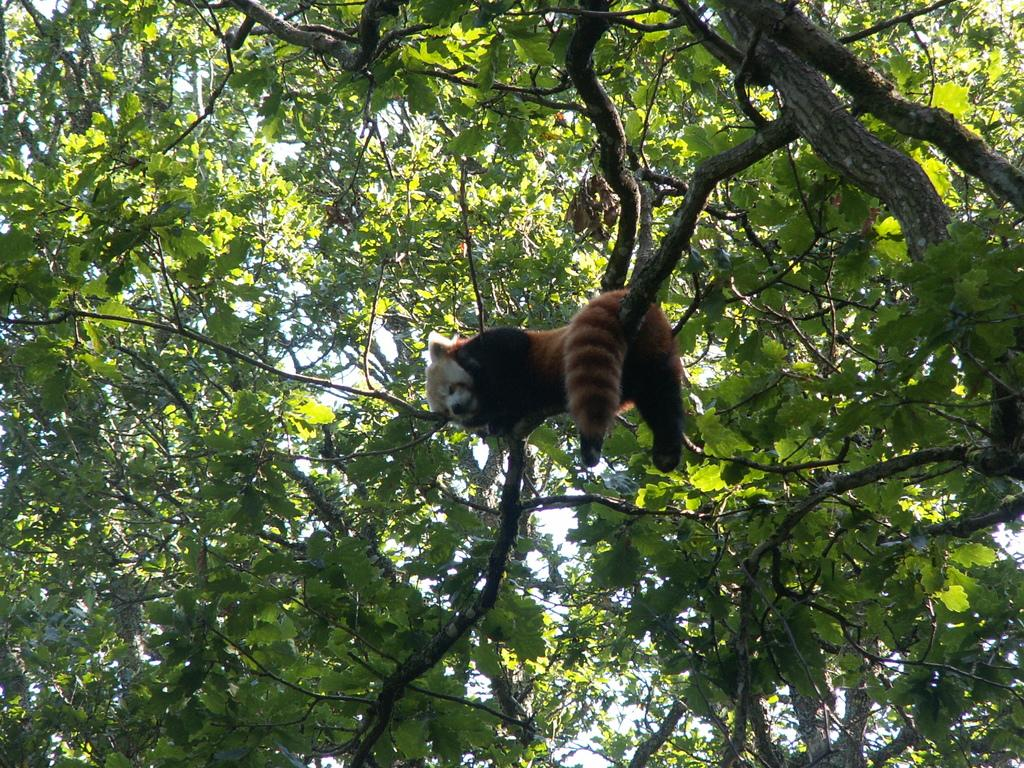What is present in the image? There is a tree in the image. Can you describe the tree in the image? The tree is truncated. What else can be seen on the tree? There is a Red Panda on the tree. What type of maid can be seen cleaning the tree in the image? There is no maid present in the image, and the tree is not being cleaned. 